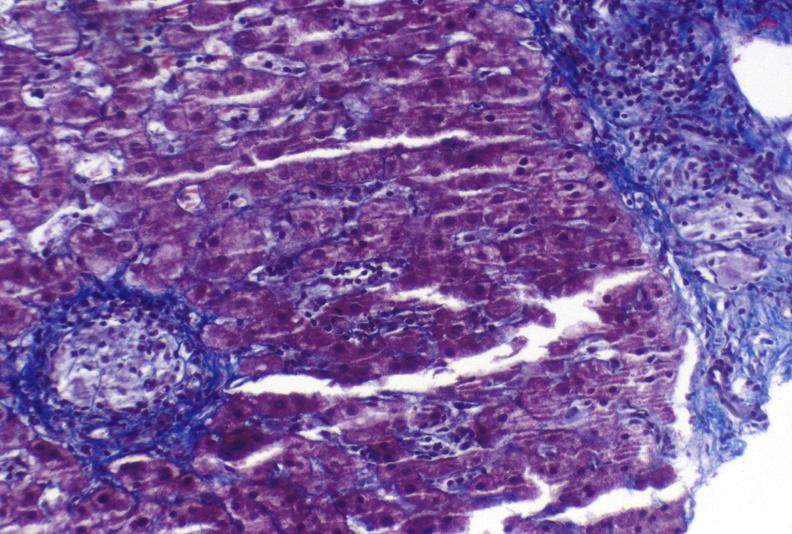s liver present?
Answer the question using a single word or phrase. Yes 